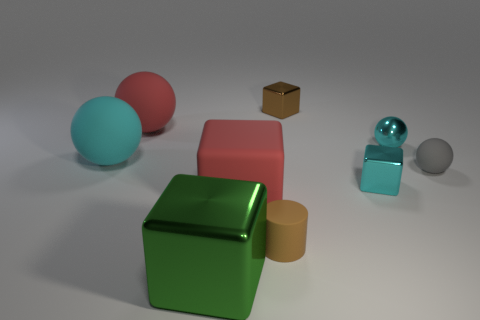Subtract all spheres. How many objects are left? 5 Subtract 0 blue blocks. How many objects are left? 9 Subtract all big matte spheres. Subtract all small purple shiny balls. How many objects are left? 7 Add 4 shiny objects. How many shiny objects are left? 8 Add 7 tiny brown blocks. How many tiny brown blocks exist? 8 